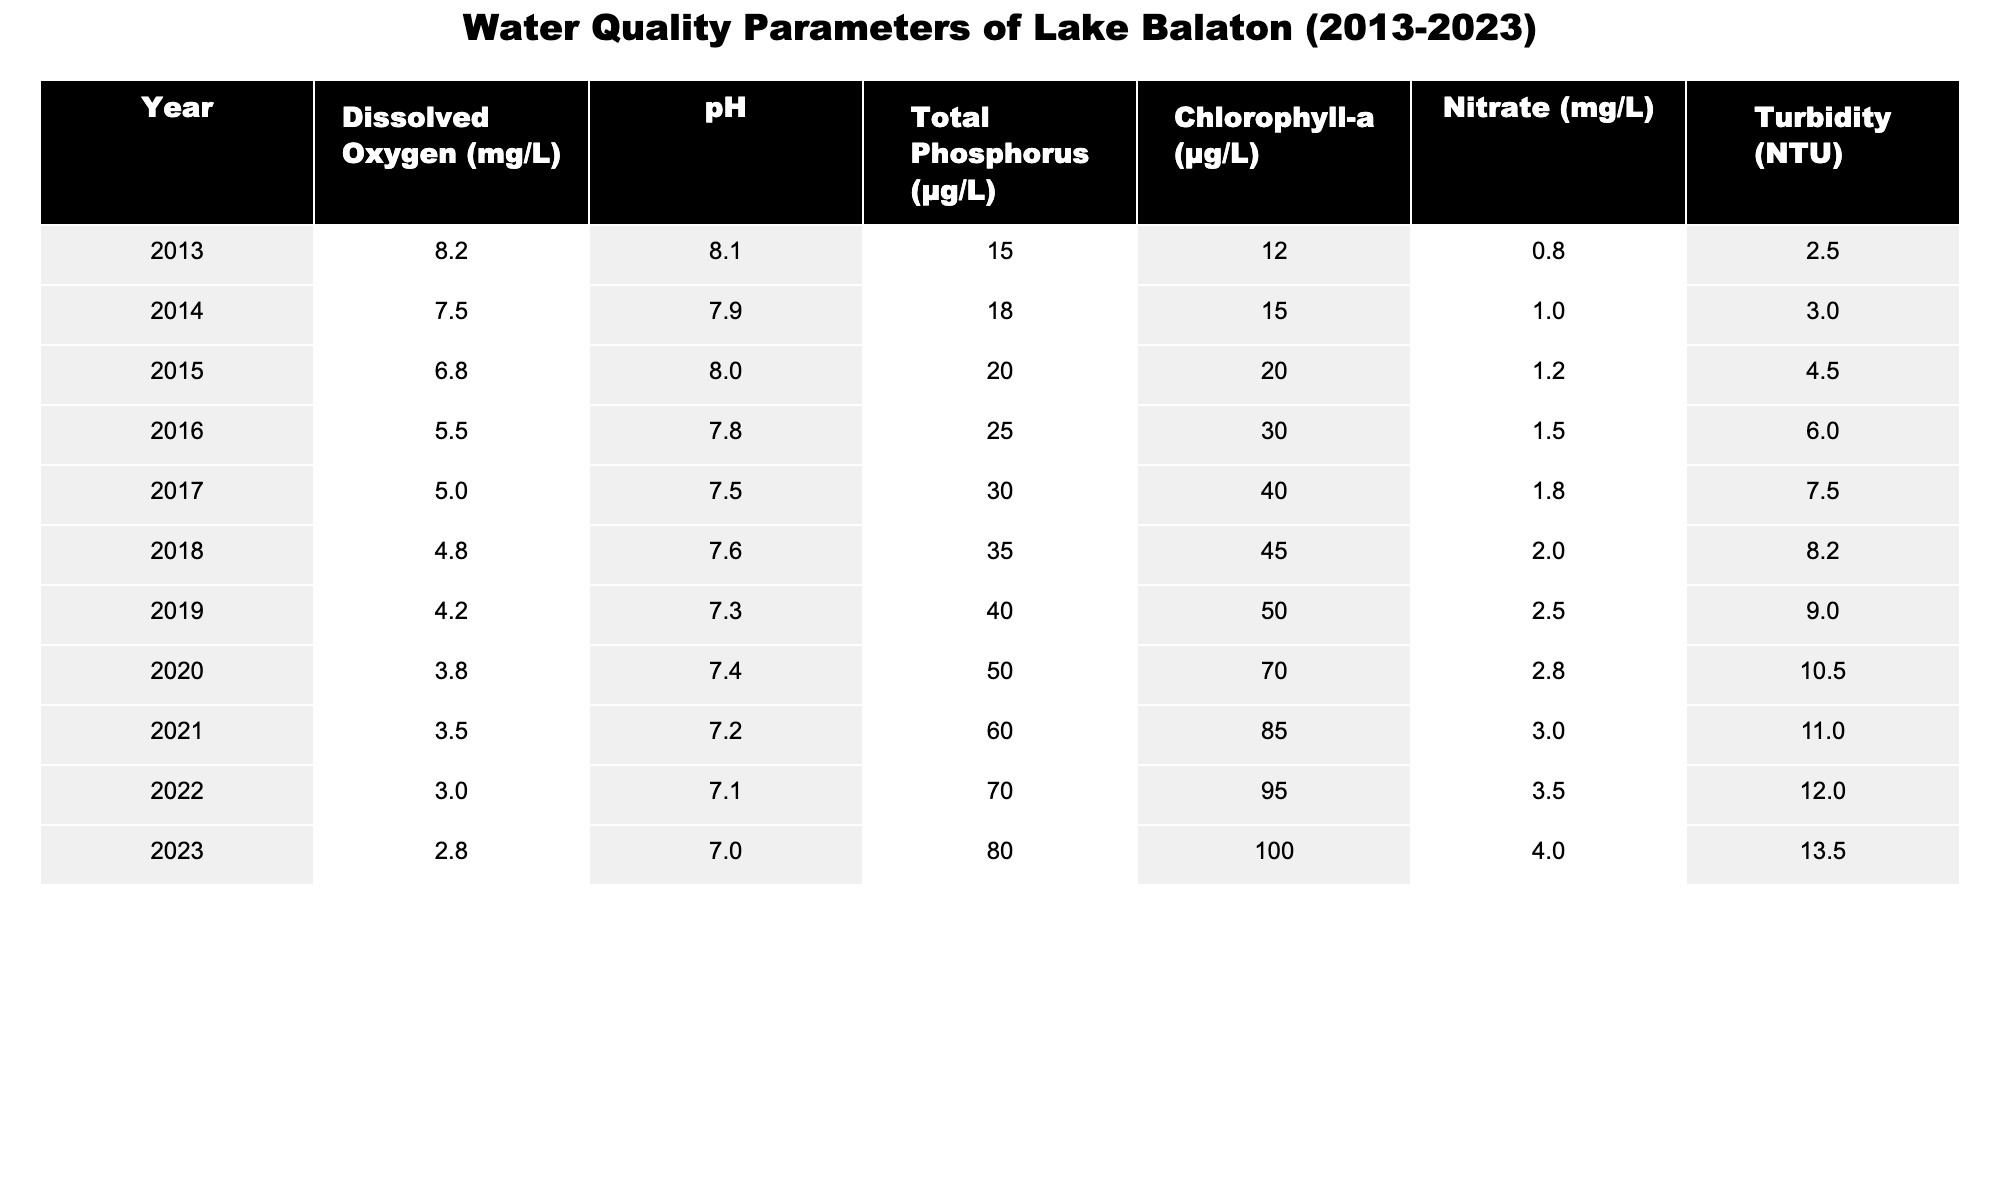What is the pH value in 2020? By locating the row for the year 2020 in the table, we can see the pH value listed under that year, which is 7.4.
Answer: 7.4 What was the highest recorded Chlorophyll-a concentration over the decade? Referring to the table, the greatest Chlorophyll-a value is seen in 2023, which is 100 µg/L.
Answer: 100 µg/L What is the trend in the Dissolved Oxygen levels from 2013 to 2023? Observing the data in the Dissolved Oxygen column, it shows a consistent decline from 8.2 mg/L in 2013 to 2.8 mg/L in 2023.
Answer: Decreasing trend What was the Total Phosphorus concentration in 2015 compared to 2019? Comparing the values in the Total Phosphorus column for 2015 (20 µg/L) and 2019 (40 µg/L), we can see that 2019 had a higher concentration.
Answer: 2019 had a higher concentration Was the Nitrate level ever below 1 mg/L during the decade? By examining the Nitrate column, we note that the lowest value recorded is 0.8 mg/L for the year 2013, thus making it clear that it was never below 1 mg/L after that year.
Answer: No What is the average Turbidity over the years 2016 to 2020? First, sum the Turbidity values from 2016 to 2020: 6.0 + 7.5 + 8.2 + 10.5 + 11.0 = 43.2. Then, divide by the number of years (5), which gives an average of 8.64 NTU.
Answer: 8.64 NTU In which year was the Nitrate level highest, and what was its value? Looking at the Nitrate column, the highest value is found in 2023 at 4.0 mg/L.
Answer: 2023, 4.0 mg/L What was the difference in pH levels between 2013 and 2022? The pH value in 2013 is 8.1, and in 2022 it is 7.1. The difference can be calculated as 8.1 - 7.1 = 1.0.
Answer: 1.0 Which year recorded the maximum Turbidity, and what was that value? The Turbidity column reveals that 2023 had the highest recorded turbidity of 13.5 NTU.
Answer: 2023, 13.5 NTU Was there a significant drop in Dissolved Oxygen from 2018 to 2019? The Dissolved Oxygen value dropped from 4.8 mg/L in 2018 to 4.2 mg/L in 2019. This decrease of 0.6 mg/L represents a significant reduction.
Answer: Yes What percentage increase in Total Phosphorus was observed from 2013 to 2023? The change in Total Phosphorus is from 15 µg/L in 2013 to 80 µg/L in 2023. The increase is 80 - 15 = 65 µg/L. To find the percentage increase, divide the increase by the original value: (65/15) * 100 = 433.33%.
Answer: 433.33% 